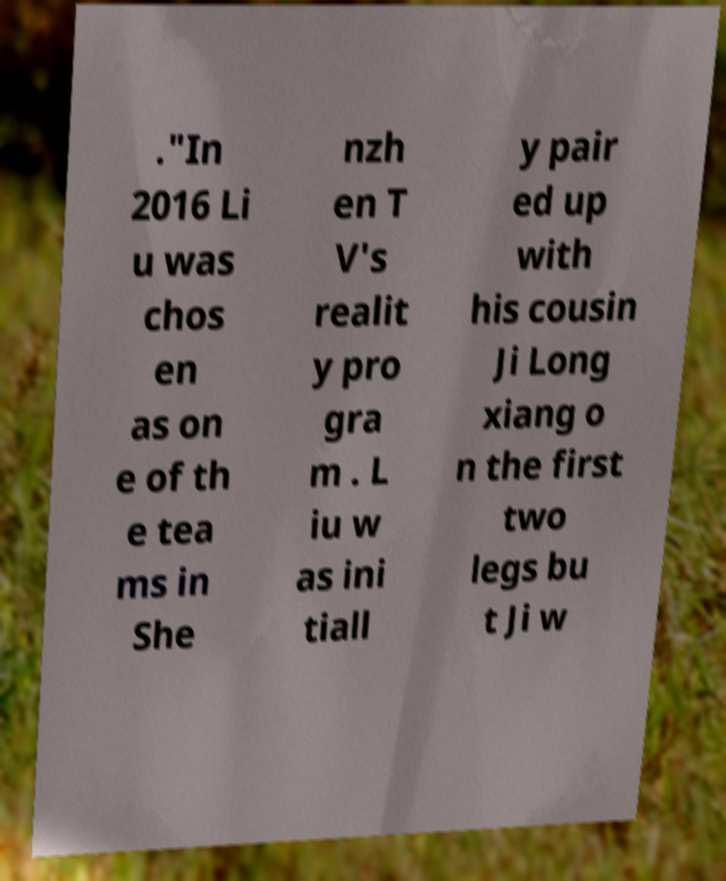For documentation purposes, I need the text within this image transcribed. Could you provide that? ."In 2016 Li u was chos en as on e of th e tea ms in She nzh en T V's realit y pro gra m . L iu w as ini tiall y pair ed up with his cousin Ji Long xiang o n the first two legs bu t Ji w 